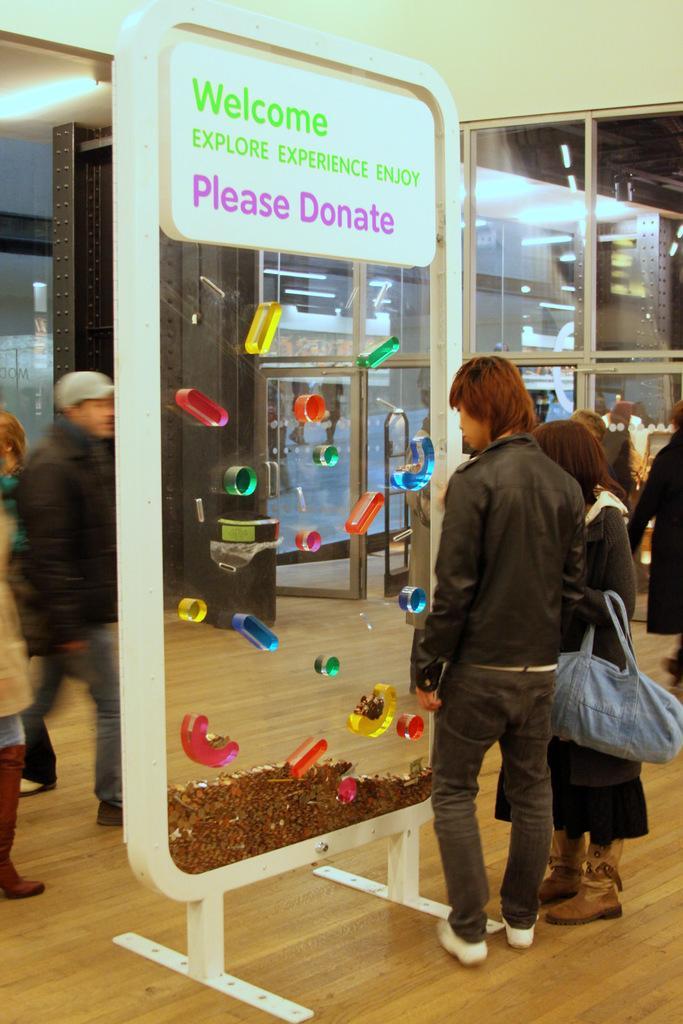How would you summarize this image in a sentence or two? This picture is clicked in a mall. Here, we see man and woman standing beside a whiteboard on which some text is written. Behind that, we see man in black jacket is walking. Behind that, we see buildings and windows. 